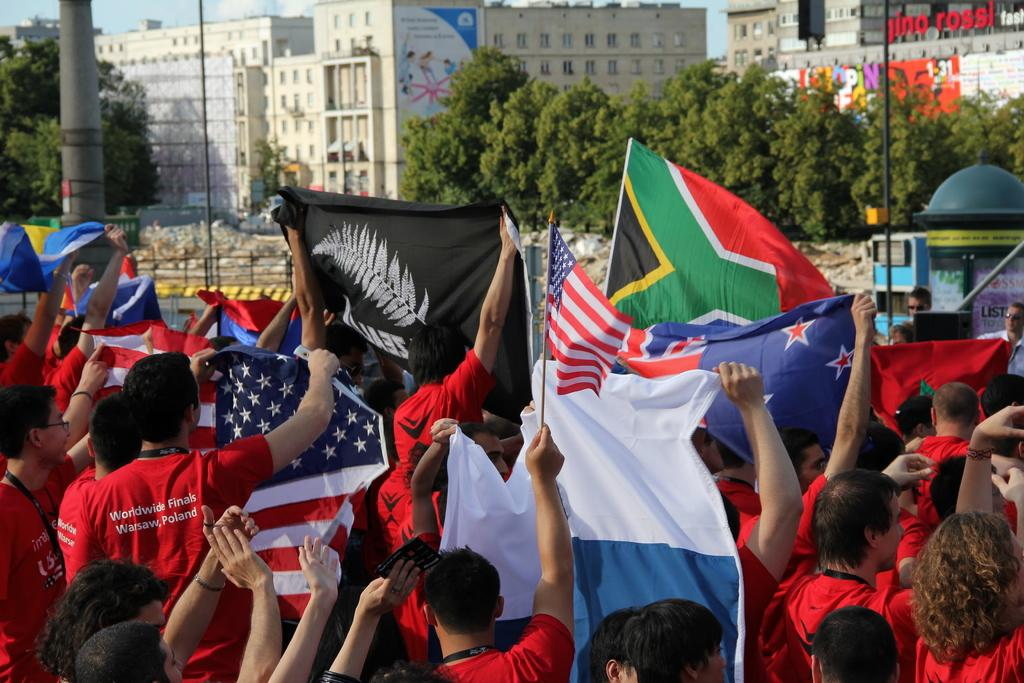What can be seen in the image involving multiple individuals? There are groups of people in the image. What are the people holding in the image? The people are holding different flags in the image. What type of natural elements are present in the image? There are trees in the image. What type of man-made structures can be seen in the image? There are buildings in the image. What type of work is being done by the people in the image? There is no indication of work being done in the image; the people are holding flags, which suggests they might be participating in a gathering or event. 